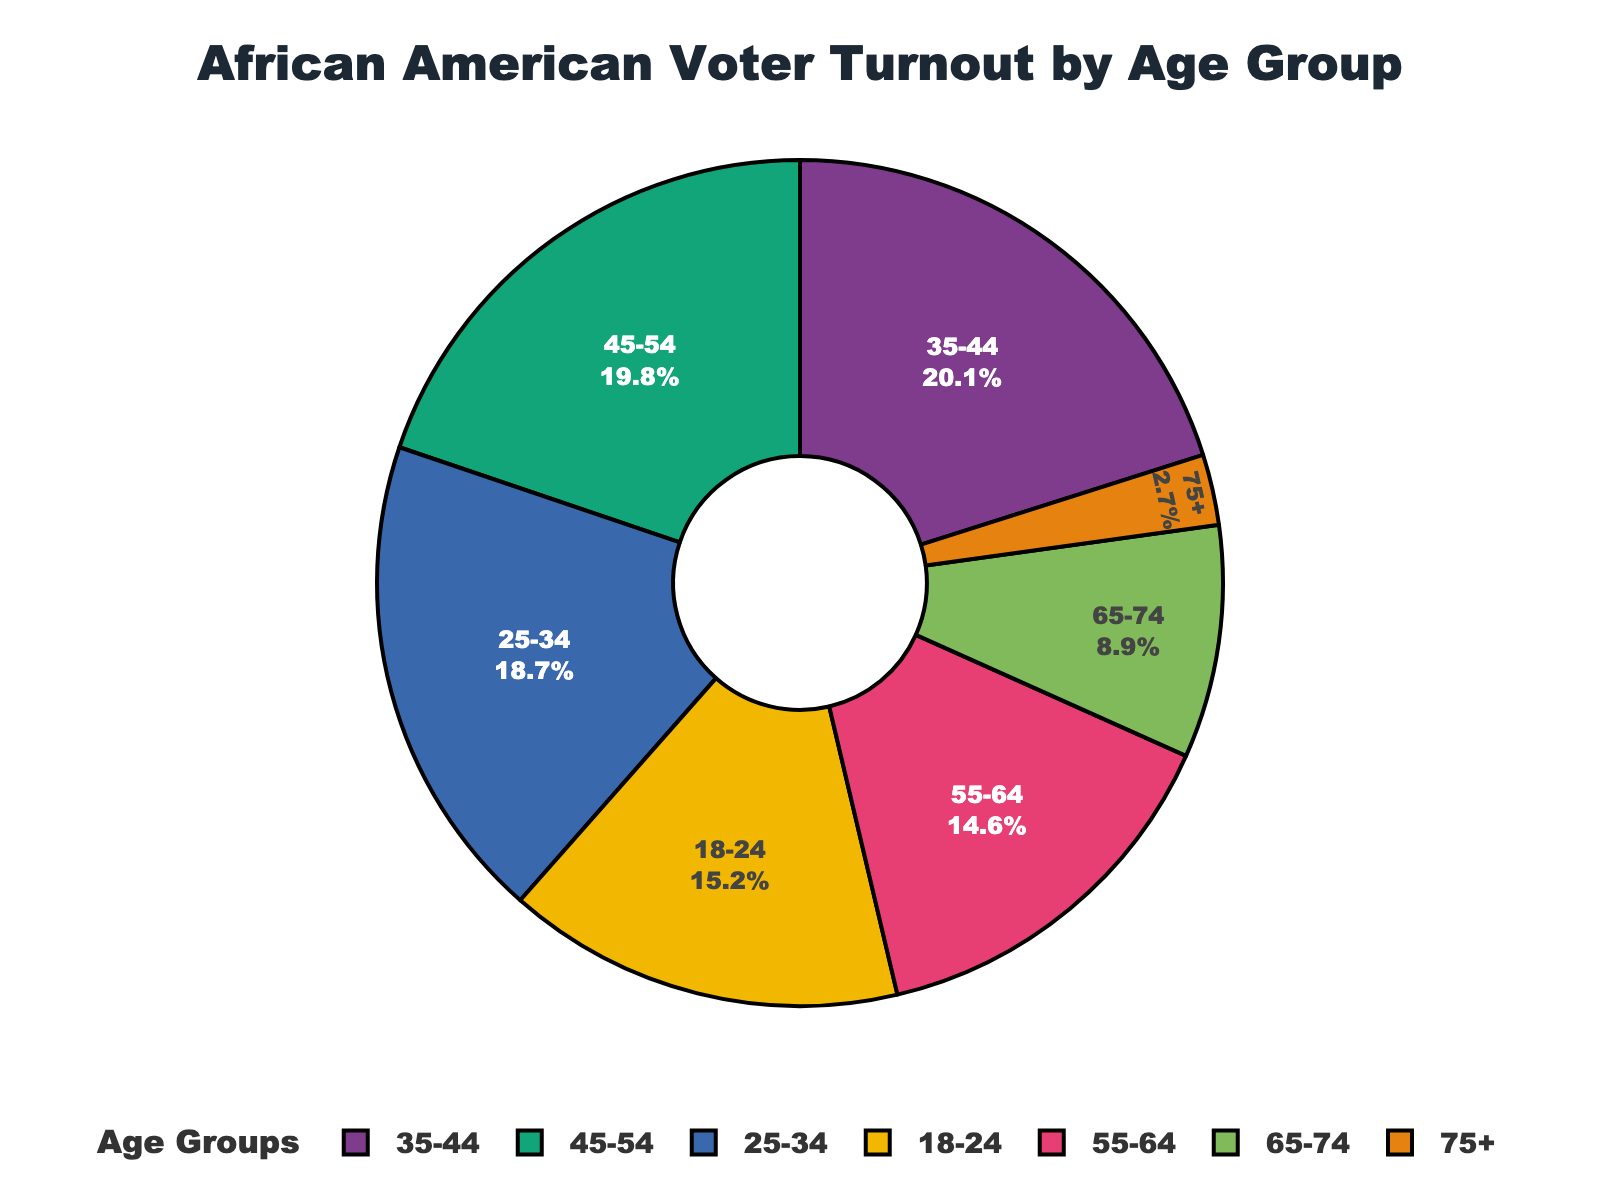What age group has the highest percentage of voter turnout? The pie chart shows different segments representing different age groups. The largest segment represents the age group 35-44 with 20.1%.
Answer: 35-44 What is the combined percentage of voter turnout for the age groups 18-24 and 75+? To find the combined percentage, add the percentages of the age groups 18-24 (15.2%) and 75+ (2.7%): 15.2 + 2.7 = 17.9%.
Answer: 17.9% Which age group has a smaller voter turnout percentage: 25-34 or 55-64? By examining the chart, the age group 55-64 (14.6%) has a smaller percentage than 25-34 (18.7%).
Answer: 55-64 What is the age group with a voter turnout percentage of less than 5%? By looking at the pie chart, the 75+ age group is the only one with a percentage less than 5%, which is 2.7%.
Answer: 75+ How much more is the combined voter turnout percentage of age groups 35-44 and 45-54 compared to 55-64 and 65-74? First, sum the percentages of 35-44 and 45-54: 20.1 + 19.8 = 39.9. Then, sum 55-64 and 65-74: 14.6 + 8.9 = 23.5. The difference is 39.9 - 23.5 = 16.4%.
Answer: 16.4% Which age group's voter turnout is almost equal to the sum of the voter turnouts of the age groups 45-54 and 65-74? Sum the percentages of the age groups 45-54 and 65-74: 19.8 + 8.9 = 28.7%. Comparing this to other age groups, none are exactly 28.7%, but age group 35-44 (20.1%) is the closest in value.
Answer: None How many age groups have voter turnout percentages greater than 15%? The age groups with percentages greater than 15% are 18-24 (15.2%), 25-34 (18.7%), 35-44 (20.1%), and 45-54 (19.8%). There are 4 such age groups.
Answer: 4 